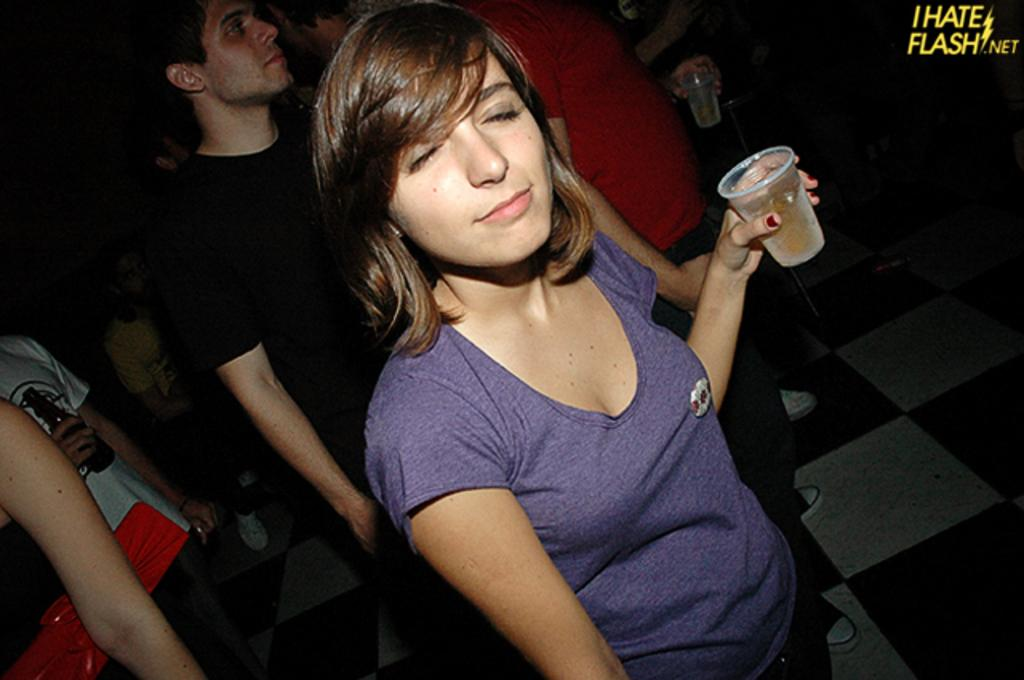Who is present in the image? There are people in the image. What is the woman holding in the image? The woman is holding a glass. How would you describe the lighting in the image? The image is dark. Can you identify any additional features in the image? There is a watermark in the image. How many balls are being juggled by the giraffe in the image? There is no giraffe or balls present in the image. 